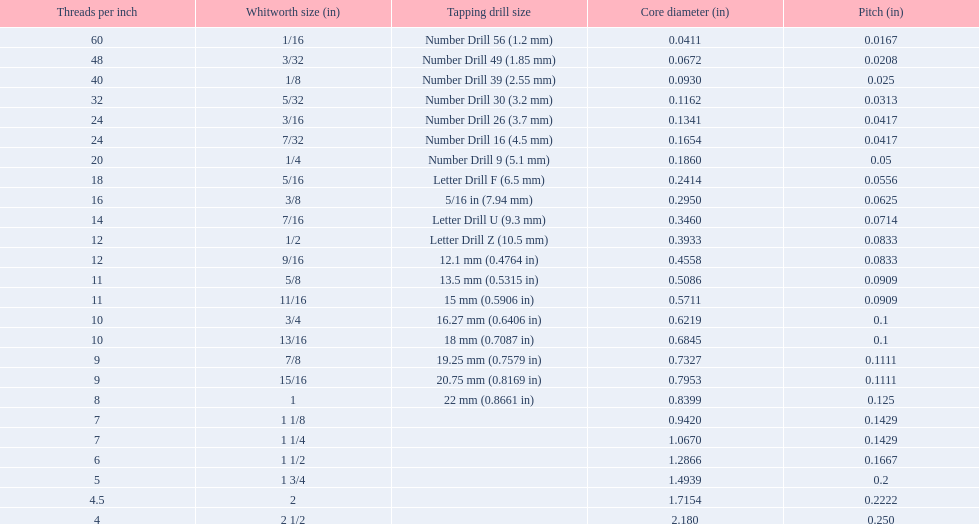What core diameter (in) comes after 0.0930? 0.1162. 